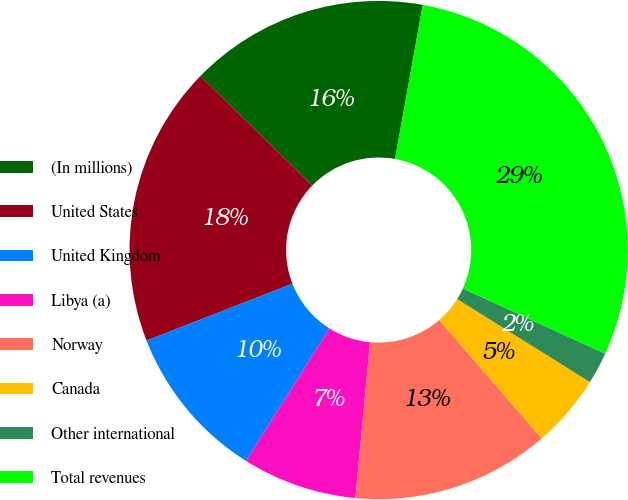Convert chart to OTSL. <chart><loc_0><loc_0><loc_500><loc_500><pie_chart><fcel>(In millions)<fcel>United States<fcel>United Kingdom<fcel>Libya (a)<fcel>Norway<fcel>Canada<fcel>Other international<fcel>Total revenues<nl><fcel>15.53%<fcel>18.22%<fcel>10.14%<fcel>7.45%<fcel>12.84%<fcel>4.76%<fcel>2.06%<fcel>28.99%<nl></chart> 